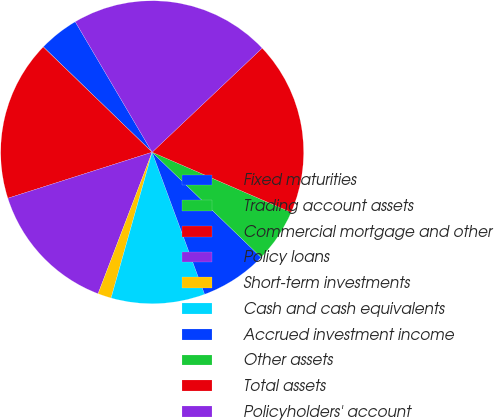Convert chart. <chart><loc_0><loc_0><loc_500><loc_500><pie_chart><fcel>Fixed maturities<fcel>Trading account assets<fcel>Commercial mortgage and other<fcel>Policy loans<fcel>Short-term investments<fcel>Cash and cash equivalents<fcel>Accrued investment income<fcel>Other assets<fcel>Total assets<fcel>Policyholders' account<nl><fcel>4.29%<fcel>0.01%<fcel>17.14%<fcel>14.28%<fcel>1.44%<fcel>10.0%<fcel>7.15%<fcel>5.72%<fcel>18.56%<fcel>21.42%<nl></chart> 